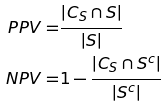<formula> <loc_0><loc_0><loc_500><loc_500>P P V = & \frac { | C _ { S } \cap S | } { | S | } \\ N P V = & 1 - \frac { | C _ { S } \cap S ^ { c } | } { | S ^ { c } | }</formula> 